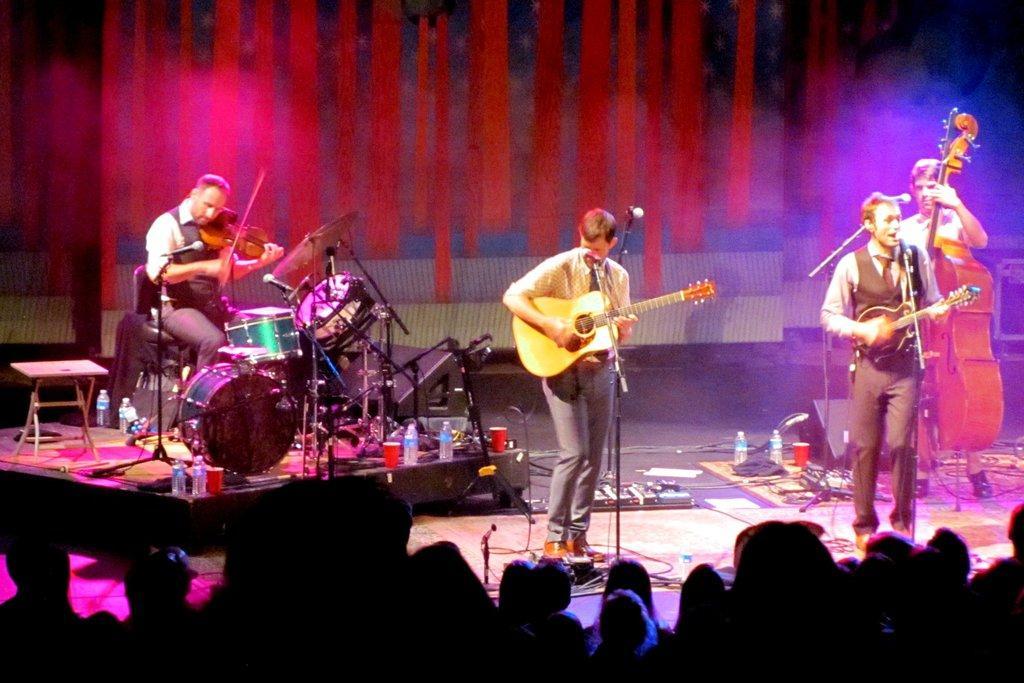Could you give a brief overview of what you see in this image? In this image there are group of persons who are playing musical instruments and at the bottom of the image there are spectators and at the background of the image there is a red color sheet. 